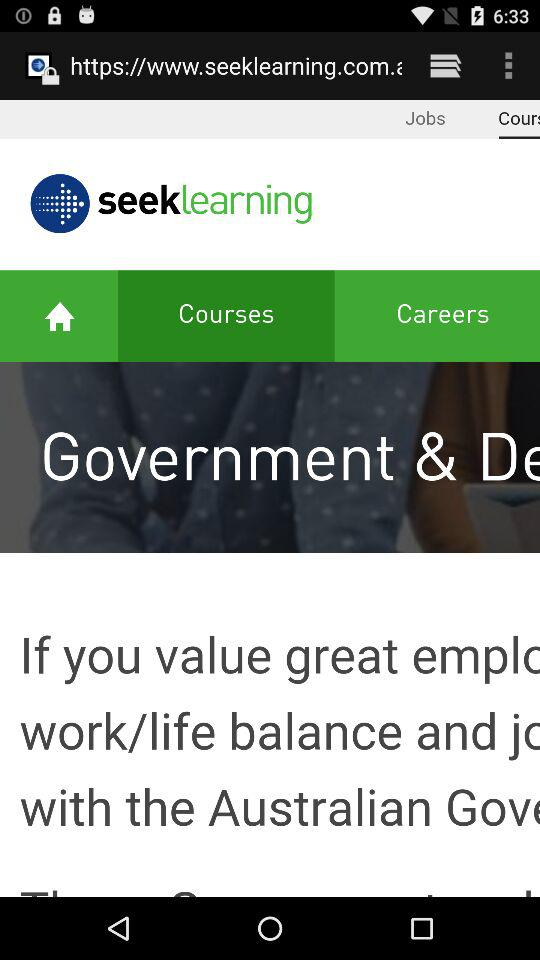What is the application name? The application name is "seeklearning". 